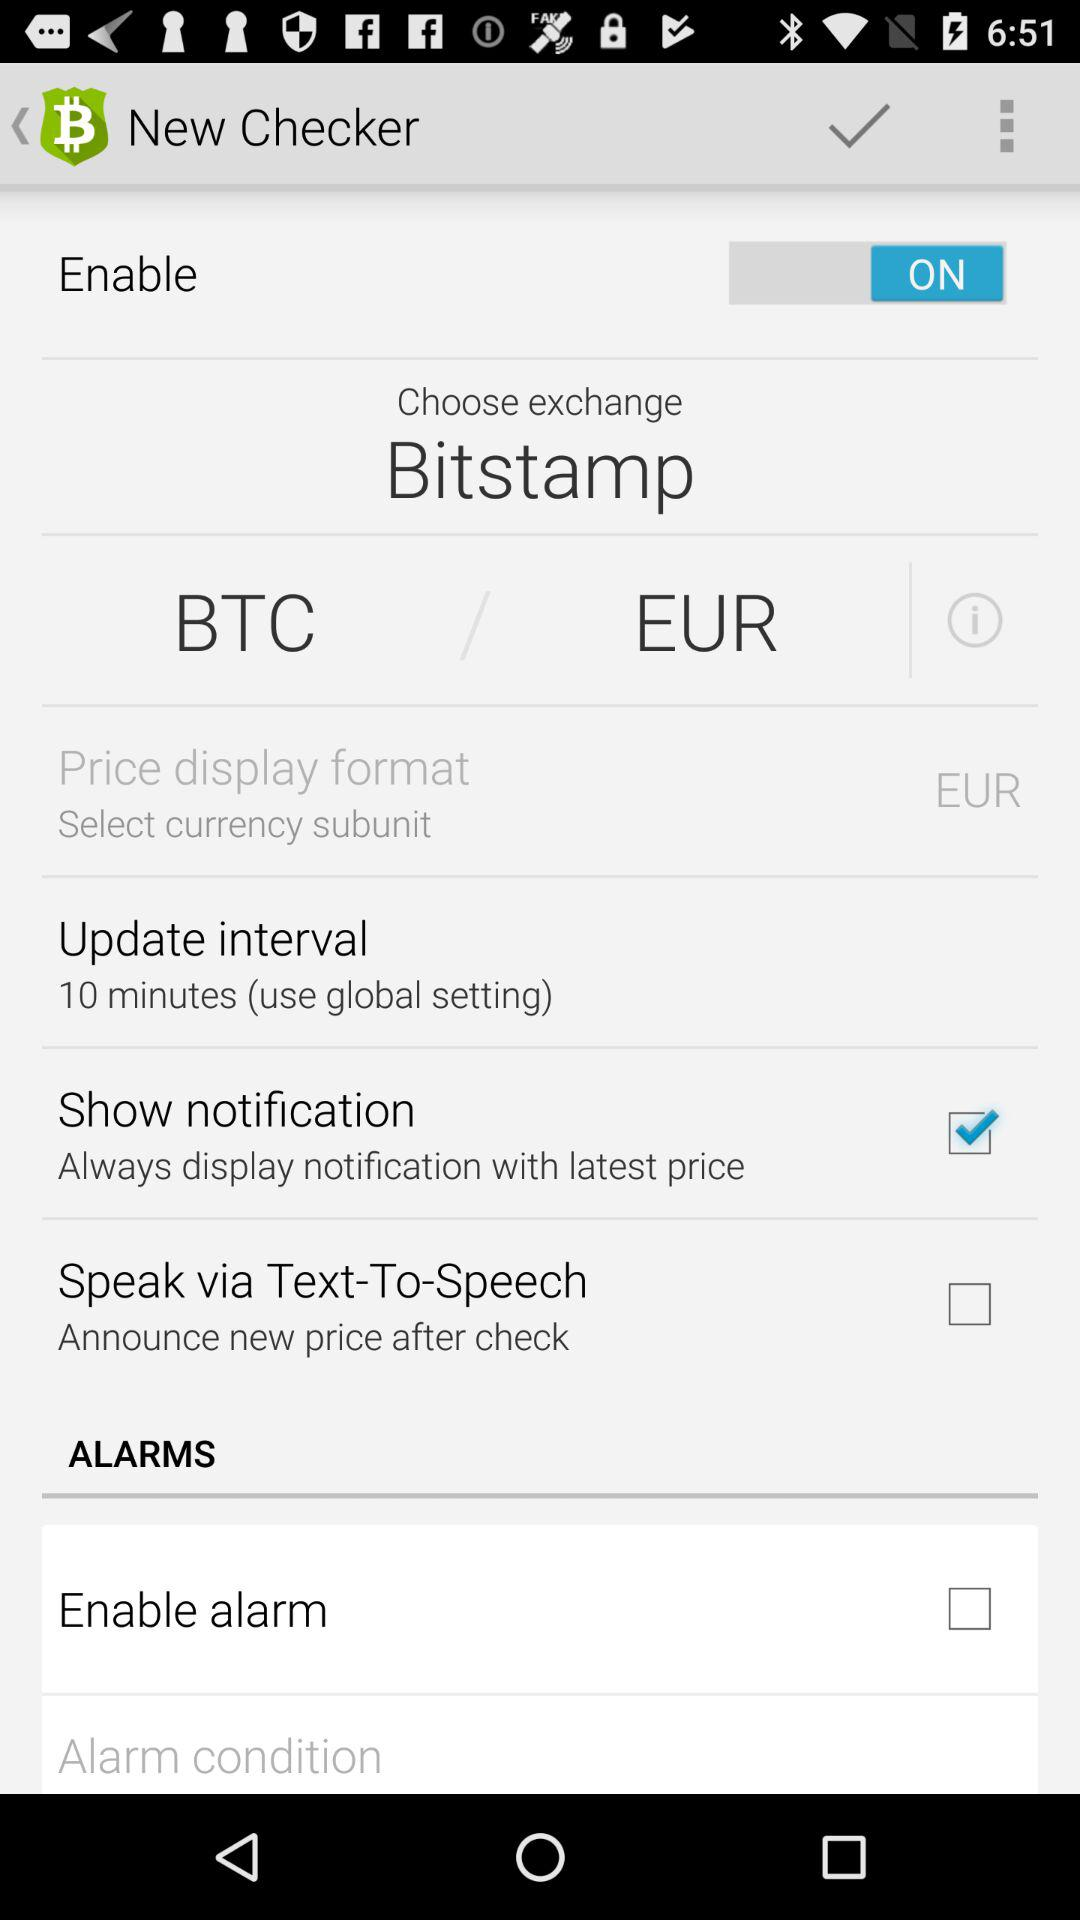Which currency is selected in the "Price display format"? The selected currency in the "Price display format" is EUR. 